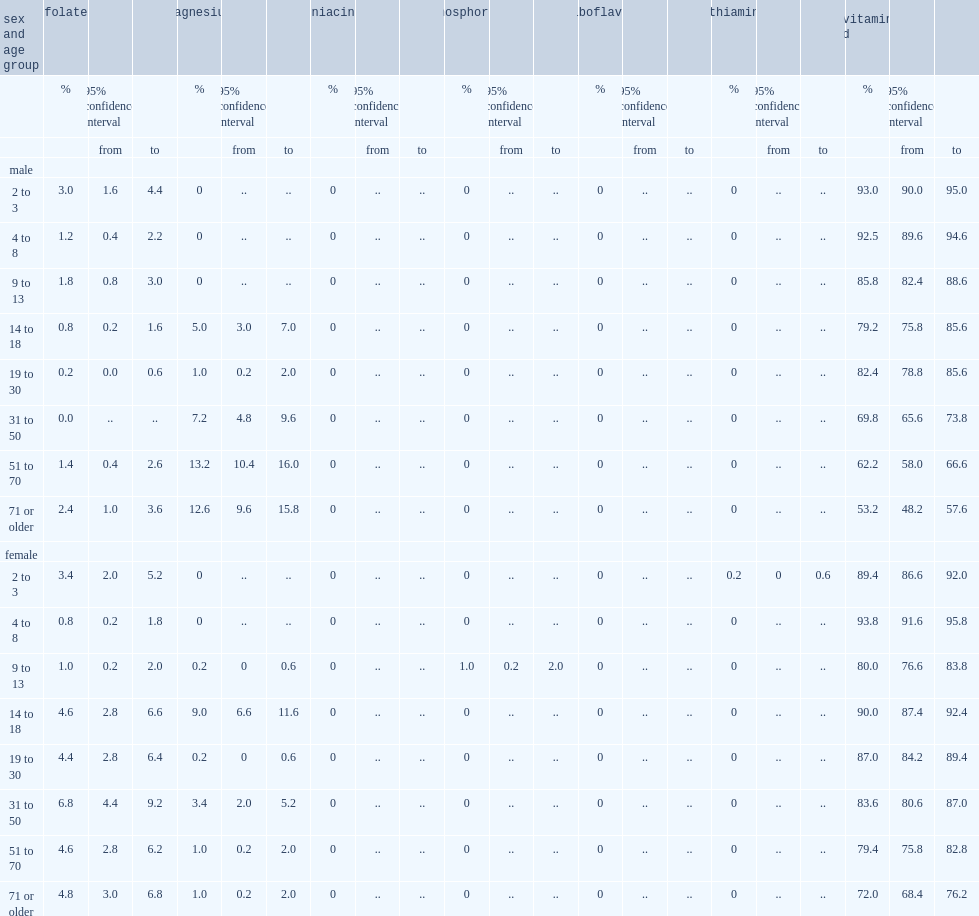List all the age/sex groups for which the vitamin d content of the simulated diets did not meet the assessment criteria of less than 10% of simulated diets below the ear. Sex and age group. 